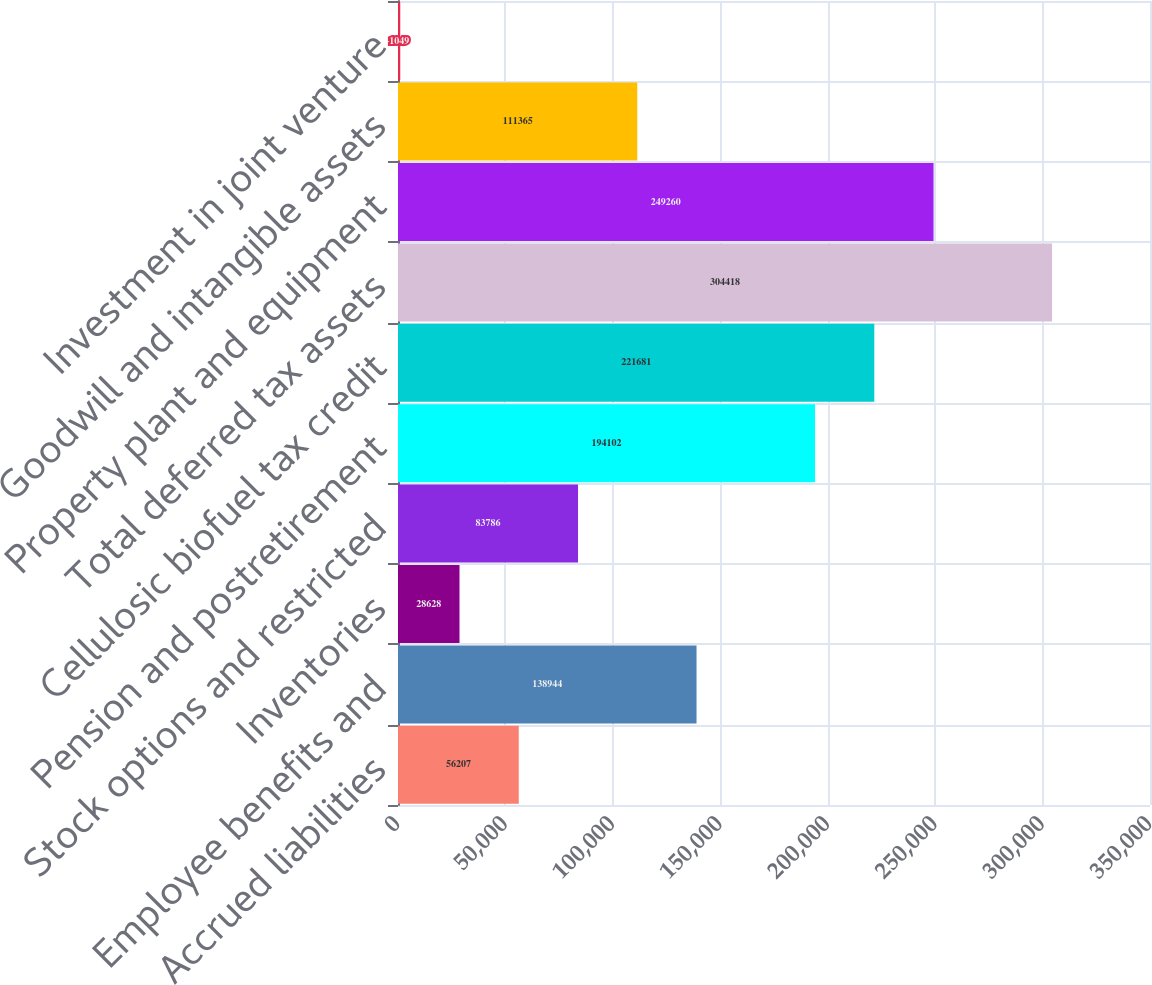Convert chart to OTSL. <chart><loc_0><loc_0><loc_500><loc_500><bar_chart><fcel>Accrued liabilities<fcel>Employee benefits and<fcel>Inventories<fcel>Stock options and restricted<fcel>Pension and postretirement<fcel>Cellulosic biofuel tax credit<fcel>Total deferred tax assets<fcel>Property plant and equipment<fcel>Goodwill and intangible assets<fcel>Investment in joint venture<nl><fcel>56207<fcel>138944<fcel>28628<fcel>83786<fcel>194102<fcel>221681<fcel>304418<fcel>249260<fcel>111365<fcel>1049<nl></chart> 